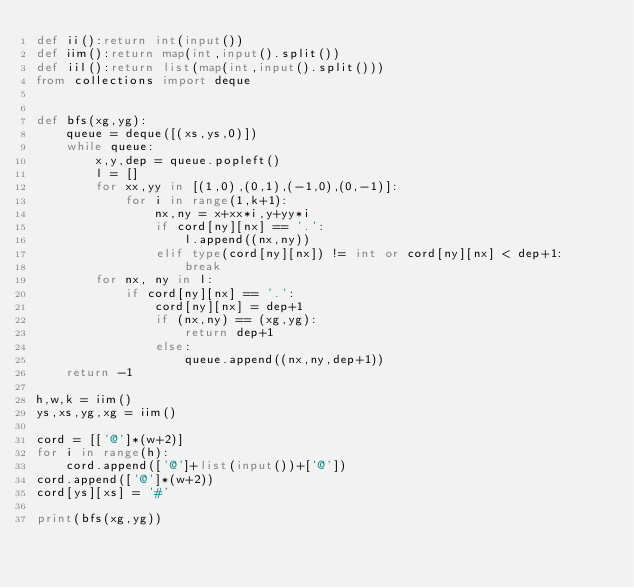<code> <loc_0><loc_0><loc_500><loc_500><_Python_>def ii():return int(input())
def iim():return map(int,input().split())
def iil():return list(map(int,input().split()))
from collections import deque


def bfs(xg,yg):
    queue = deque([(xs,ys,0)])
    while queue:
        x,y,dep = queue.popleft()
        l = []
        for xx,yy in [(1,0),(0,1),(-1,0),(0,-1)]:
            for i in range(1,k+1):
                nx,ny = x+xx*i,y+yy*i
                if cord[ny][nx] == '.':
                    l.append((nx,ny))
                elif type(cord[ny][nx]) != int or cord[ny][nx] < dep+1:
                    break
        for nx, ny in l:
            if cord[ny][nx] == '.':
                cord[ny][nx] = dep+1
                if (nx,ny) == (xg,yg):
                    return dep+1
                else:
                    queue.append((nx,ny,dep+1))
    return -1

h,w,k = iim()
ys,xs,yg,xg = iim()

cord = [['@']*(w+2)]
for i in range(h):
    cord.append(['@']+list(input())+['@'])
cord.append(['@']*(w+2))
cord[ys][xs] = '#'

print(bfs(xg,yg))
</code> 